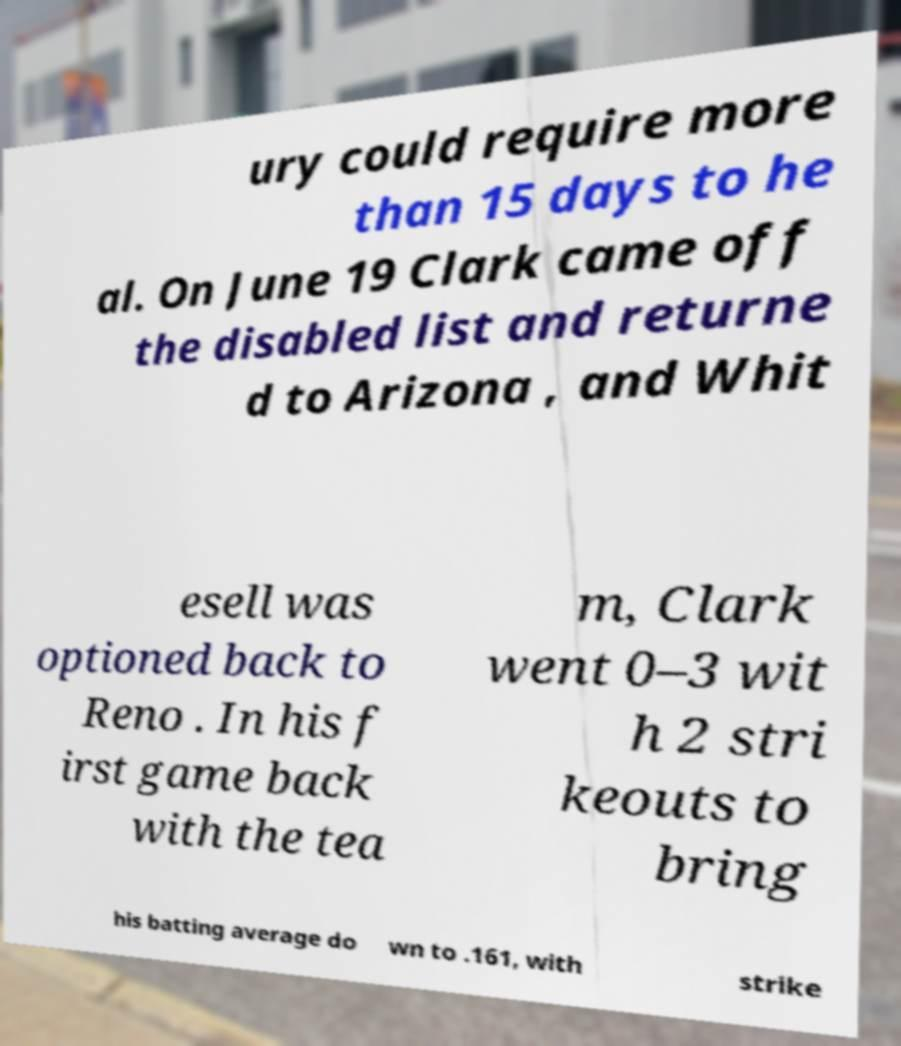Could you extract and type out the text from this image? ury could require more than 15 days to he al. On June 19 Clark came off the disabled list and returne d to Arizona , and Whit esell was optioned back to Reno . In his f irst game back with the tea m, Clark went 0–3 wit h 2 stri keouts to bring his batting average do wn to .161, with strike 